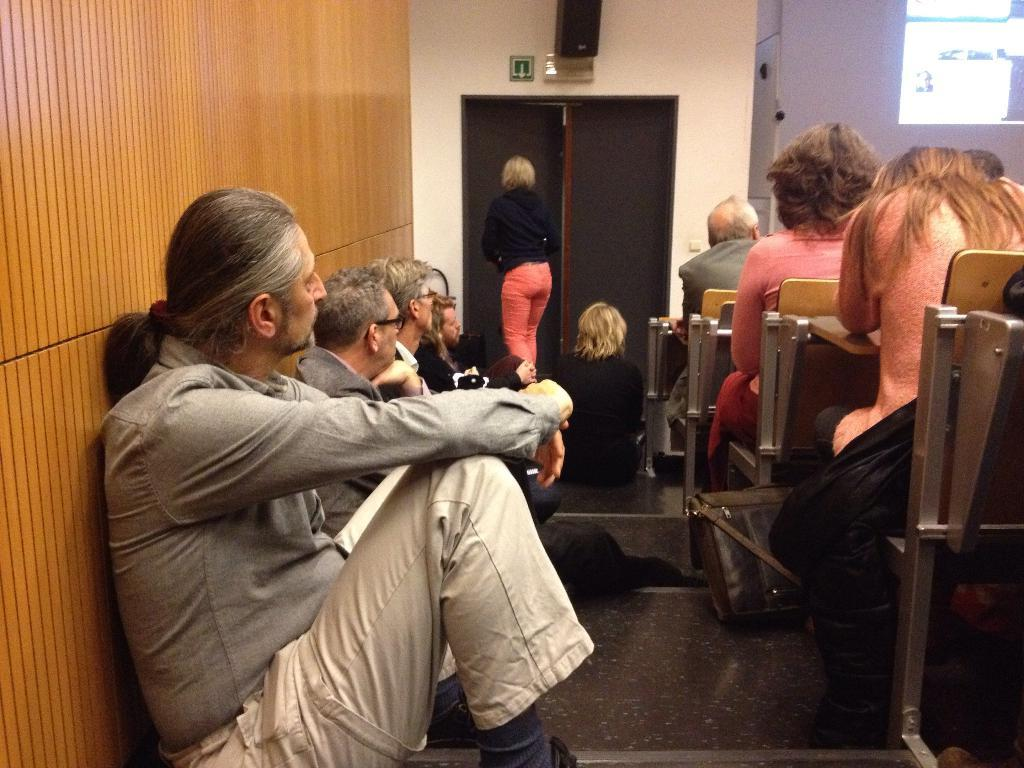What is the main subject of the image? The main subject of the image is a group of people. What can be seen in the background of the image? There is a door and a wall in the background of the image. How many rats are sitting on the heads of the people in the image? There are no rats present in the image; it only features a group of people and a door and wall in the background. 